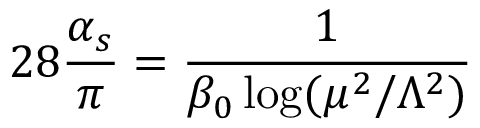Convert formula to latex. <formula><loc_0><loc_0><loc_500><loc_500>2 8 \frac { \alpha _ { s } } { \pi } = \frac { 1 } { \beta _ { 0 } \log ( \mu ^ { 2 } / \Lambda ^ { 2 } ) }</formula> 